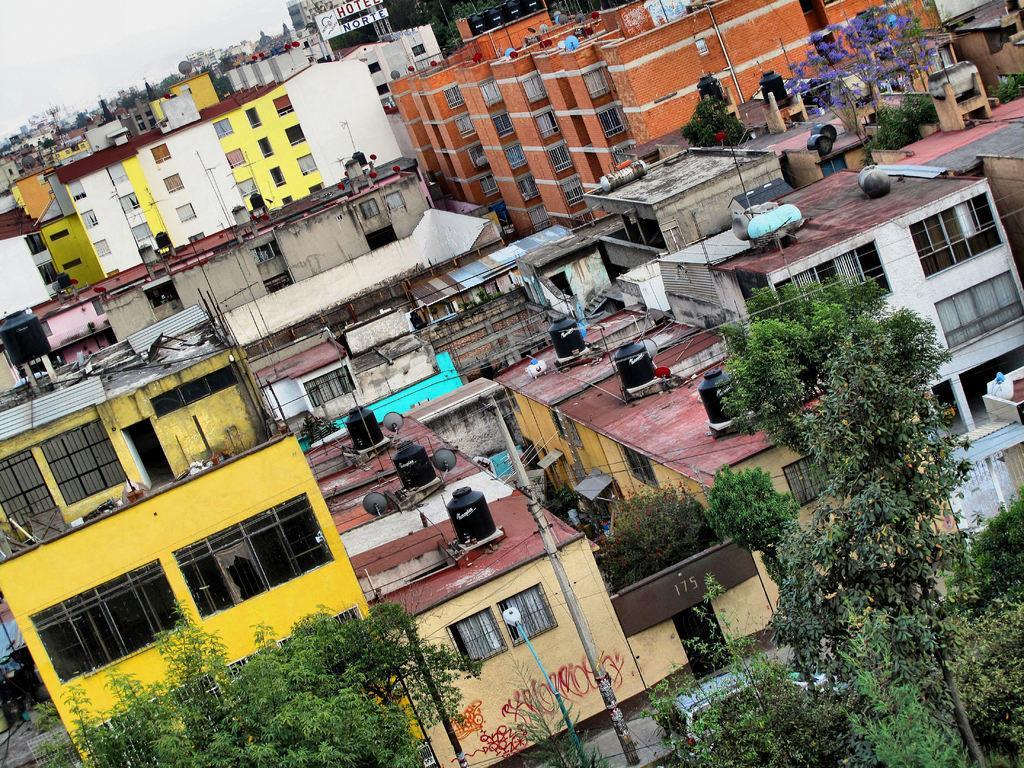In one or two sentences, can you explain what this image depicts? In this picture I can see buildings, trees, poles, and in the background there is sky. 